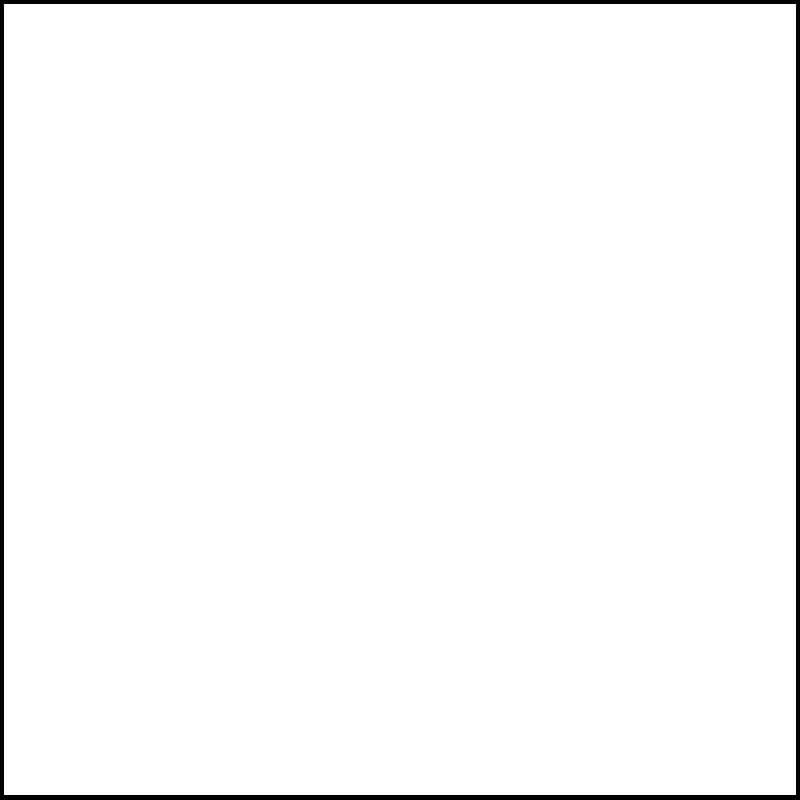Design a Faraday cage to block all wireless signals in the frequency range of 1 GHz to 5 GHz. What is the maximum mesh size (in mm) for the conductive material to ensure complete signal blockage? Assume you're using a copper mesh for construction. To design an effective Faraday cage for blocking wireless signals, we need to consider the following steps:

1. Determine the wavelength range:
   The frequency range is 1 GHz to 5 GHz.
   Using the formula $c = f\lambda$, where $c$ is the speed of light ($3 \times 10^8$ m/s), $f$ is frequency, and $\lambda$ is wavelength:
   
   For 1 GHz: $\lambda_{max} = \frac{3 \times 10^8}{1 \times 10^9} = 0.3$ m
   For 5 GHz: $\lambda_{min} = \frac{3 \times 10^8}{5 \times 10^9} = 0.06$ m

2. Calculate the maximum mesh size:
   To effectively block electromagnetic waves, the mesh size should be smaller than $\frac{1}{10}$ of the shortest wavelength.
   
   Maximum mesh size = $\frac{\lambda_{min}}{10} = \frac{0.06}{10} = 0.006$ m = 6 mm

3. Consider skin depth:
   For copper at 1 GHz, the skin depth is approximately 2 μm, which is much smaller than our mesh size, so it's not a limiting factor.

4. Safety factor:
   To account for potential manufacturing variations and ensure complete blockage, we should apply a safety factor of about 0.8.

   Final maximum mesh size = $6 \text{ mm} \times 0.8 = 4.8$ mm

Therefore, the maximum mesh size for the copper Faraday cage should be 4.8 mm to ensure complete blockage of wireless signals in the 1 GHz to 5 GHz range.
Answer: 4.8 mm 